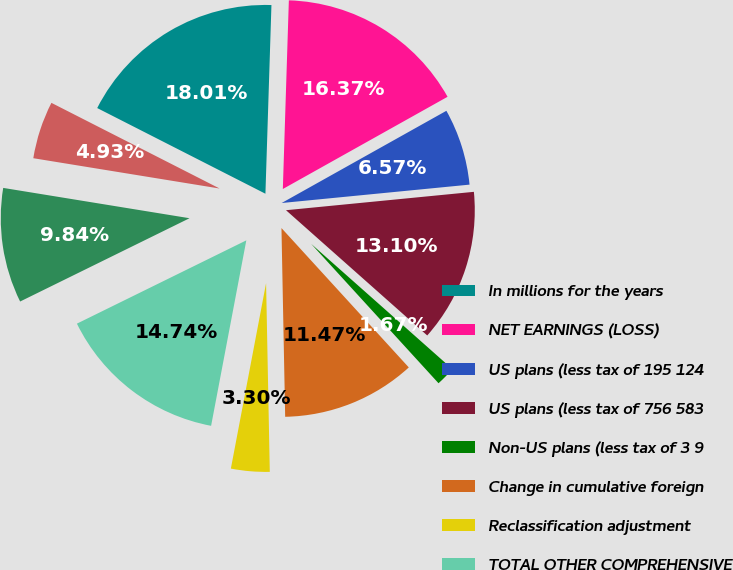Convert chart. <chart><loc_0><loc_0><loc_500><loc_500><pie_chart><fcel>In millions for the years<fcel>NET EARNINGS (LOSS)<fcel>US plans (less tax of 195 124<fcel>US plans (less tax of 756 583<fcel>Non-US plans (less tax of 3 9<fcel>Change in cumulative foreign<fcel>Reclassification adjustment<fcel>TOTAL OTHER COMPREHENSIVE<fcel>Comprehensive Income (Loss)<fcel>Net (Earnings) Loss<nl><fcel>18.01%<fcel>16.37%<fcel>6.57%<fcel>13.1%<fcel>1.67%<fcel>11.47%<fcel>3.3%<fcel>14.74%<fcel>9.84%<fcel>4.93%<nl></chart> 